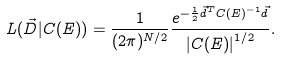Convert formula to latex. <formula><loc_0><loc_0><loc_500><loc_500>L ( \vec { D } | C ( E ) ) = \frac { 1 } { ( 2 \pi ) ^ { N / 2 } } \frac { e ^ { - \frac { 1 } { 2 } \vec { d } ^ { T } C ( E ) ^ { - 1 } \vec { d } } } { \left | C ( E ) \right | ^ { 1 / 2 } } .</formula> 